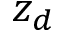<formula> <loc_0><loc_0><loc_500><loc_500>z _ { d }</formula> 